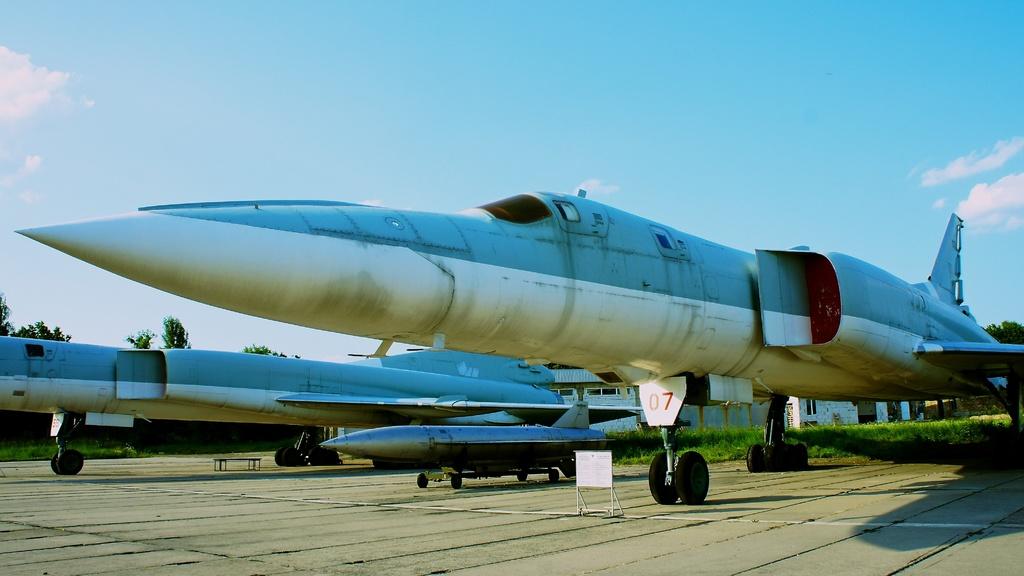What is the number in red on the plane?
Provide a succinct answer. 07. 